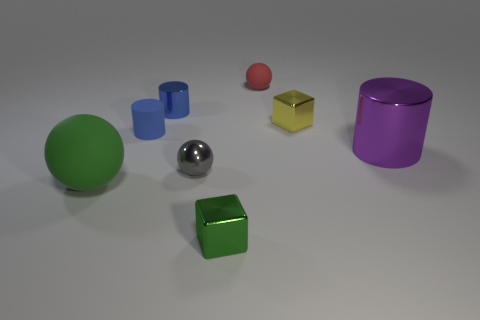The object that is the same color as the tiny shiny cylinder is what shape?
Your response must be concise. Cylinder. How many tiny things are either cyan metallic cubes or green shiny blocks?
Provide a short and direct response. 1. Are there any tiny yellow metallic objects that have the same shape as the small green shiny thing?
Your answer should be compact. Yes. Do the blue rubber thing and the red object have the same shape?
Offer a terse response. No. The metallic object to the right of the small metal cube that is to the right of the small green metal cube is what color?
Offer a very short reply. Purple. The metallic thing that is the same size as the green ball is what color?
Your answer should be compact. Purple. How many matte objects are large red blocks or yellow blocks?
Give a very brief answer. 0. There is a shiny block that is in front of the large sphere; what number of blue objects are on the right side of it?
Your answer should be very brief. 0. The metallic object that is the same color as the big matte ball is what size?
Keep it short and to the point. Small. What number of things are either large green objects or small metallic blocks that are behind the large purple thing?
Ensure brevity in your answer.  2. 